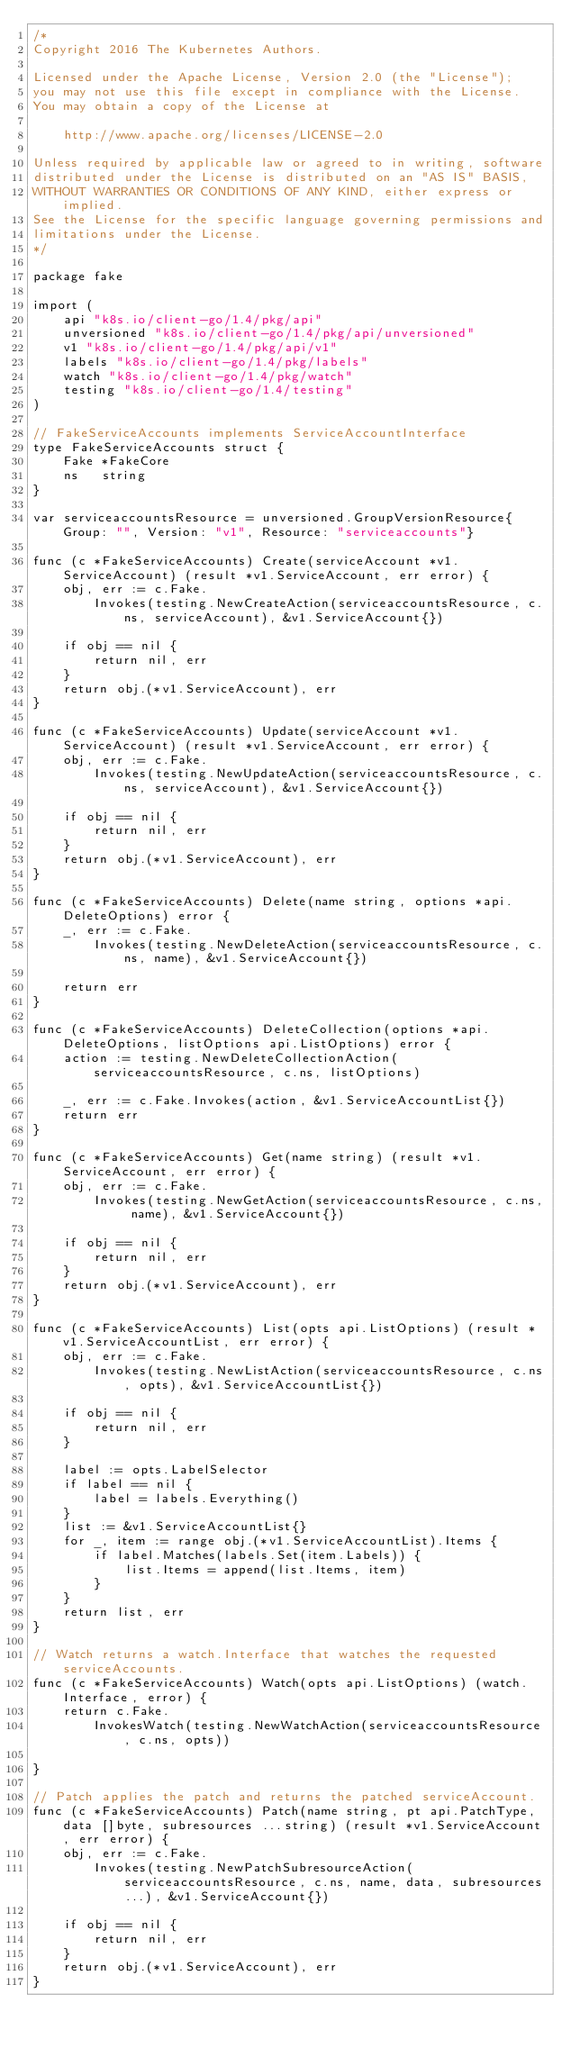<code> <loc_0><loc_0><loc_500><loc_500><_Go_>/*
Copyright 2016 The Kubernetes Authors.

Licensed under the Apache License, Version 2.0 (the "License");
you may not use this file except in compliance with the License.
You may obtain a copy of the License at

    http://www.apache.org/licenses/LICENSE-2.0

Unless required by applicable law or agreed to in writing, software
distributed under the License is distributed on an "AS IS" BASIS,
WITHOUT WARRANTIES OR CONDITIONS OF ANY KIND, either express or implied.
See the License for the specific language governing permissions and
limitations under the License.
*/

package fake

import (
	api "k8s.io/client-go/1.4/pkg/api"
	unversioned "k8s.io/client-go/1.4/pkg/api/unversioned"
	v1 "k8s.io/client-go/1.4/pkg/api/v1"
	labels "k8s.io/client-go/1.4/pkg/labels"
	watch "k8s.io/client-go/1.4/pkg/watch"
	testing "k8s.io/client-go/1.4/testing"
)

// FakeServiceAccounts implements ServiceAccountInterface
type FakeServiceAccounts struct {
	Fake *FakeCore
	ns   string
}

var serviceaccountsResource = unversioned.GroupVersionResource{Group: "", Version: "v1", Resource: "serviceaccounts"}

func (c *FakeServiceAccounts) Create(serviceAccount *v1.ServiceAccount) (result *v1.ServiceAccount, err error) {
	obj, err := c.Fake.
		Invokes(testing.NewCreateAction(serviceaccountsResource, c.ns, serviceAccount), &v1.ServiceAccount{})

	if obj == nil {
		return nil, err
	}
	return obj.(*v1.ServiceAccount), err
}

func (c *FakeServiceAccounts) Update(serviceAccount *v1.ServiceAccount) (result *v1.ServiceAccount, err error) {
	obj, err := c.Fake.
		Invokes(testing.NewUpdateAction(serviceaccountsResource, c.ns, serviceAccount), &v1.ServiceAccount{})

	if obj == nil {
		return nil, err
	}
	return obj.(*v1.ServiceAccount), err
}

func (c *FakeServiceAccounts) Delete(name string, options *api.DeleteOptions) error {
	_, err := c.Fake.
		Invokes(testing.NewDeleteAction(serviceaccountsResource, c.ns, name), &v1.ServiceAccount{})

	return err
}

func (c *FakeServiceAccounts) DeleteCollection(options *api.DeleteOptions, listOptions api.ListOptions) error {
	action := testing.NewDeleteCollectionAction(serviceaccountsResource, c.ns, listOptions)

	_, err := c.Fake.Invokes(action, &v1.ServiceAccountList{})
	return err
}

func (c *FakeServiceAccounts) Get(name string) (result *v1.ServiceAccount, err error) {
	obj, err := c.Fake.
		Invokes(testing.NewGetAction(serviceaccountsResource, c.ns, name), &v1.ServiceAccount{})

	if obj == nil {
		return nil, err
	}
	return obj.(*v1.ServiceAccount), err
}

func (c *FakeServiceAccounts) List(opts api.ListOptions) (result *v1.ServiceAccountList, err error) {
	obj, err := c.Fake.
		Invokes(testing.NewListAction(serviceaccountsResource, c.ns, opts), &v1.ServiceAccountList{})

	if obj == nil {
		return nil, err
	}

	label := opts.LabelSelector
	if label == nil {
		label = labels.Everything()
	}
	list := &v1.ServiceAccountList{}
	for _, item := range obj.(*v1.ServiceAccountList).Items {
		if label.Matches(labels.Set(item.Labels)) {
			list.Items = append(list.Items, item)
		}
	}
	return list, err
}

// Watch returns a watch.Interface that watches the requested serviceAccounts.
func (c *FakeServiceAccounts) Watch(opts api.ListOptions) (watch.Interface, error) {
	return c.Fake.
		InvokesWatch(testing.NewWatchAction(serviceaccountsResource, c.ns, opts))

}

// Patch applies the patch and returns the patched serviceAccount.
func (c *FakeServiceAccounts) Patch(name string, pt api.PatchType, data []byte, subresources ...string) (result *v1.ServiceAccount, err error) {
	obj, err := c.Fake.
		Invokes(testing.NewPatchSubresourceAction(serviceaccountsResource, c.ns, name, data, subresources...), &v1.ServiceAccount{})

	if obj == nil {
		return nil, err
	}
	return obj.(*v1.ServiceAccount), err
}
</code> 